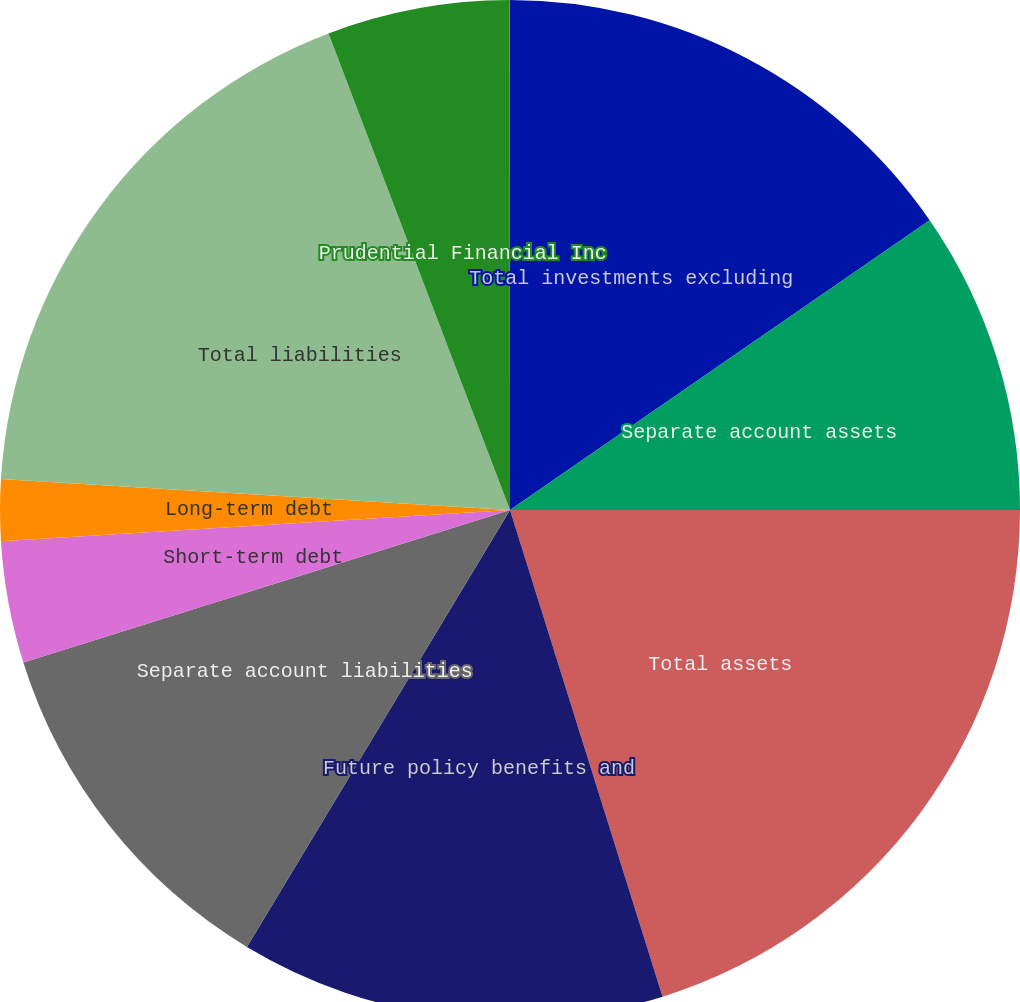Convert chart to OTSL. <chart><loc_0><loc_0><loc_500><loc_500><pie_chart><fcel>Total investments excluding<fcel>Separate account assets<fcel>Total assets<fcel>Future policy benefits and<fcel>Separate account liabilities<fcel>Short-term debt<fcel>Long-term debt<fcel>Total liabilities<fcel>Prudential Financial Inc<fcel>Noncontrolling interests<nl><fcel>15.38%<fcel>9.62%<fcel>20.16%<fcel>13.46%<fcel>11.54%<fcel>3.86%<fcel>1.94%<fcel>18.24%<fcel>5.78%<fcel>0.01%<nl></chart> 